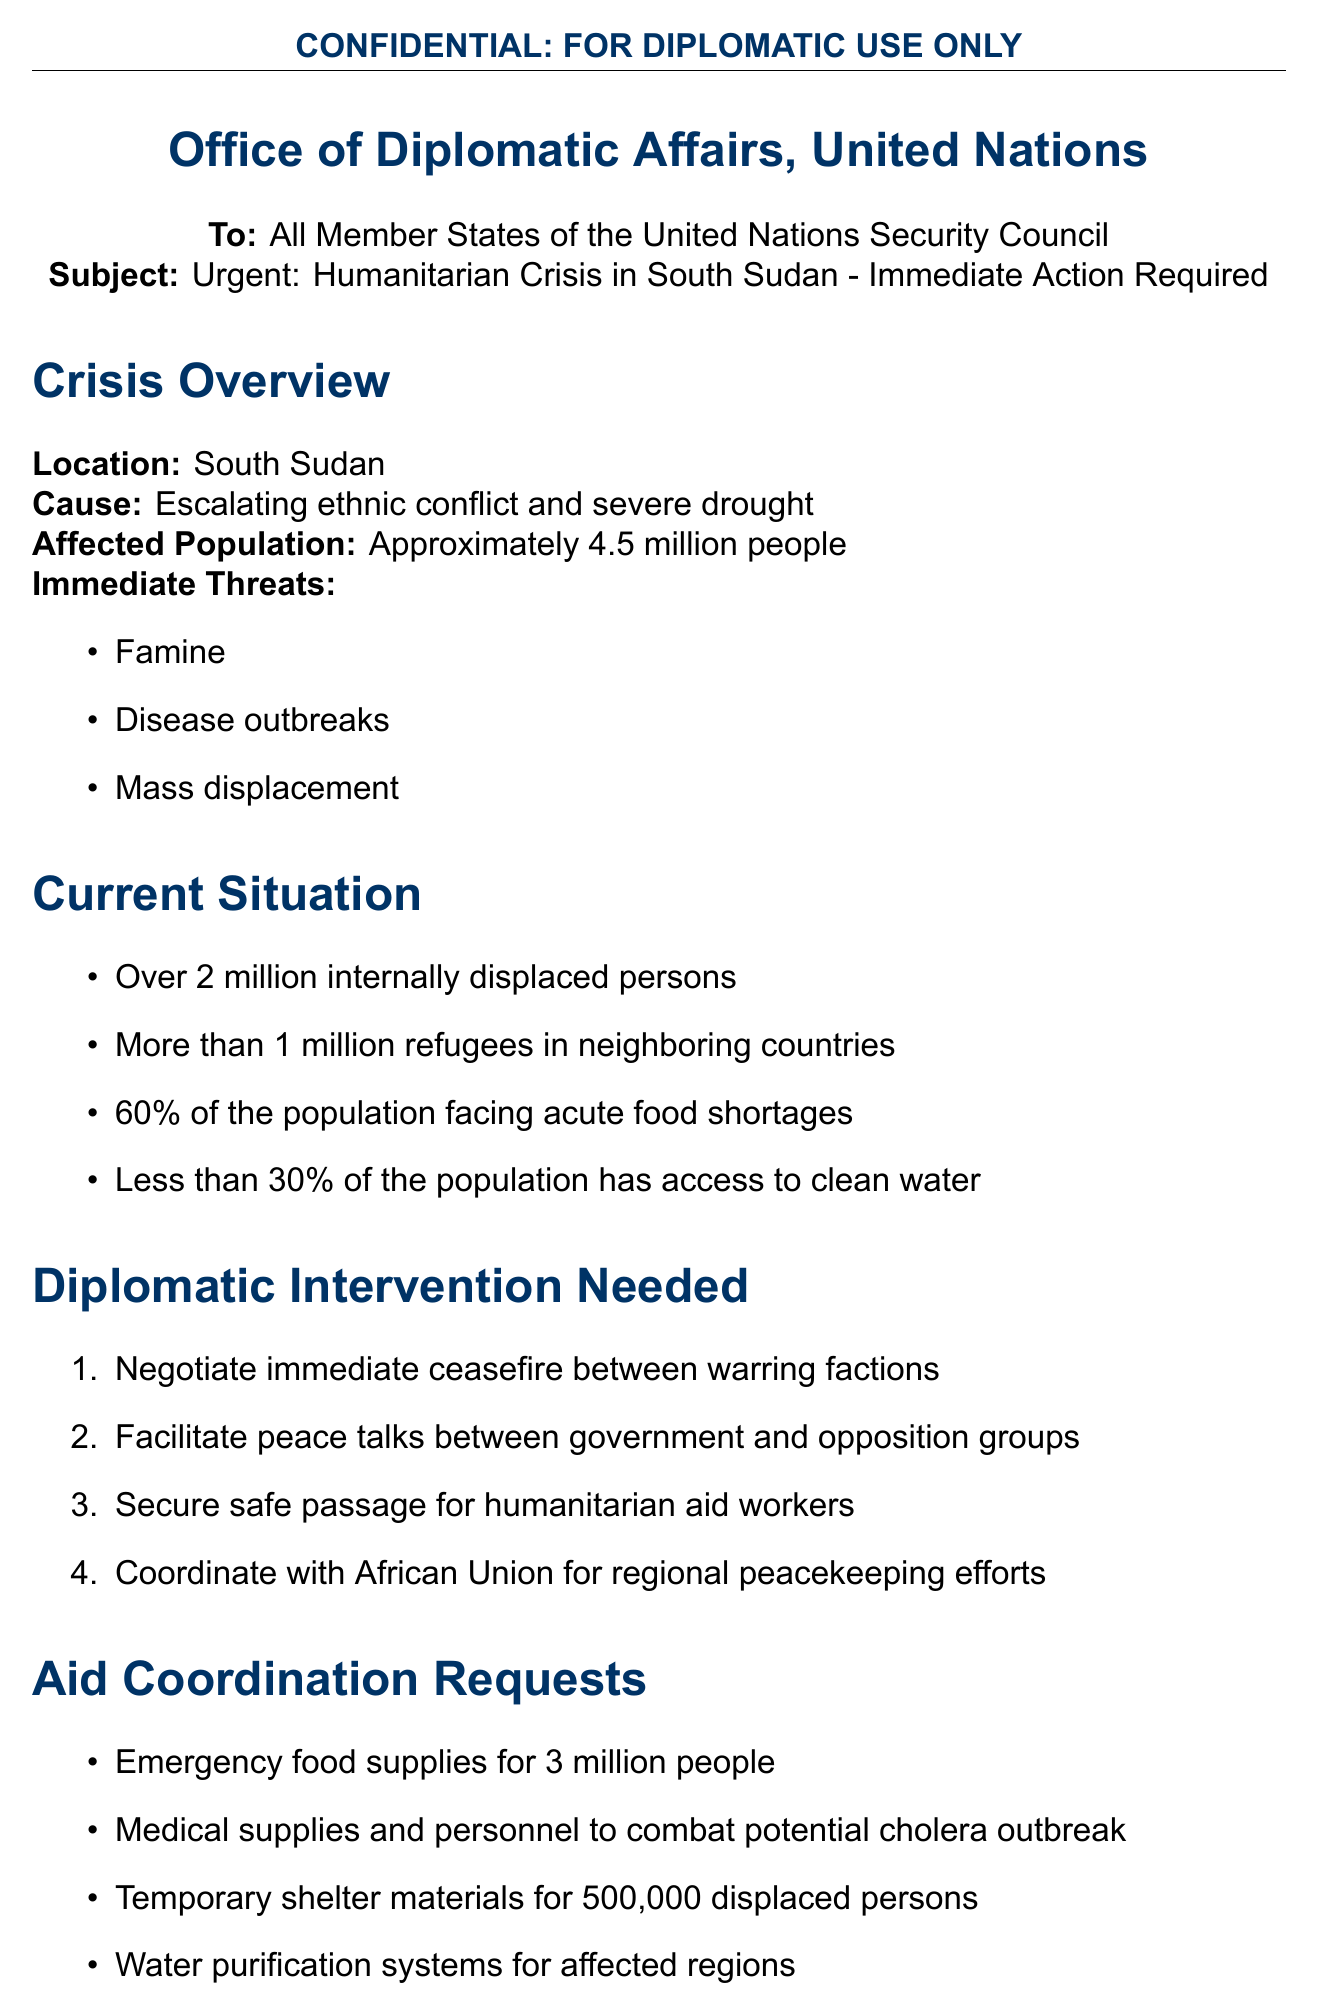What is the location of the crisis? The location of the crisis is explicitly stated in the document.
Answer: South Sudan How many people are affected by the crisis? This information is provided as an approximate count of those affected.
Answer: Approximately 4.5 million people What percentage of the population faces acute food shortages? The document states a specific percentage regarding food insecurity.
Answer: 60% What immediate action is requested for humanitarian aid delivery? This detail refers to a specific action stated in the immediate actions section.
Answer: Establish humanitarian corridors for aid delivery What type of supplies is urgently needed for 3 million people? This question addresses the specific type of aid requested in the document.
Answer: Emergency food supplies Who should be coordinated with for regional peacekeeping efforts? This question looks for a specific regional organization mentioned in the document.
Answer: African Union What is the deadline for response to the letter? The document specifies a timeframe within which a response is expected.
Answer: Within 48 hours What disease outbreak is mentioned in the document? This question focuses on a particular health threat identified in the crisis overview.
Answer: Cholera 